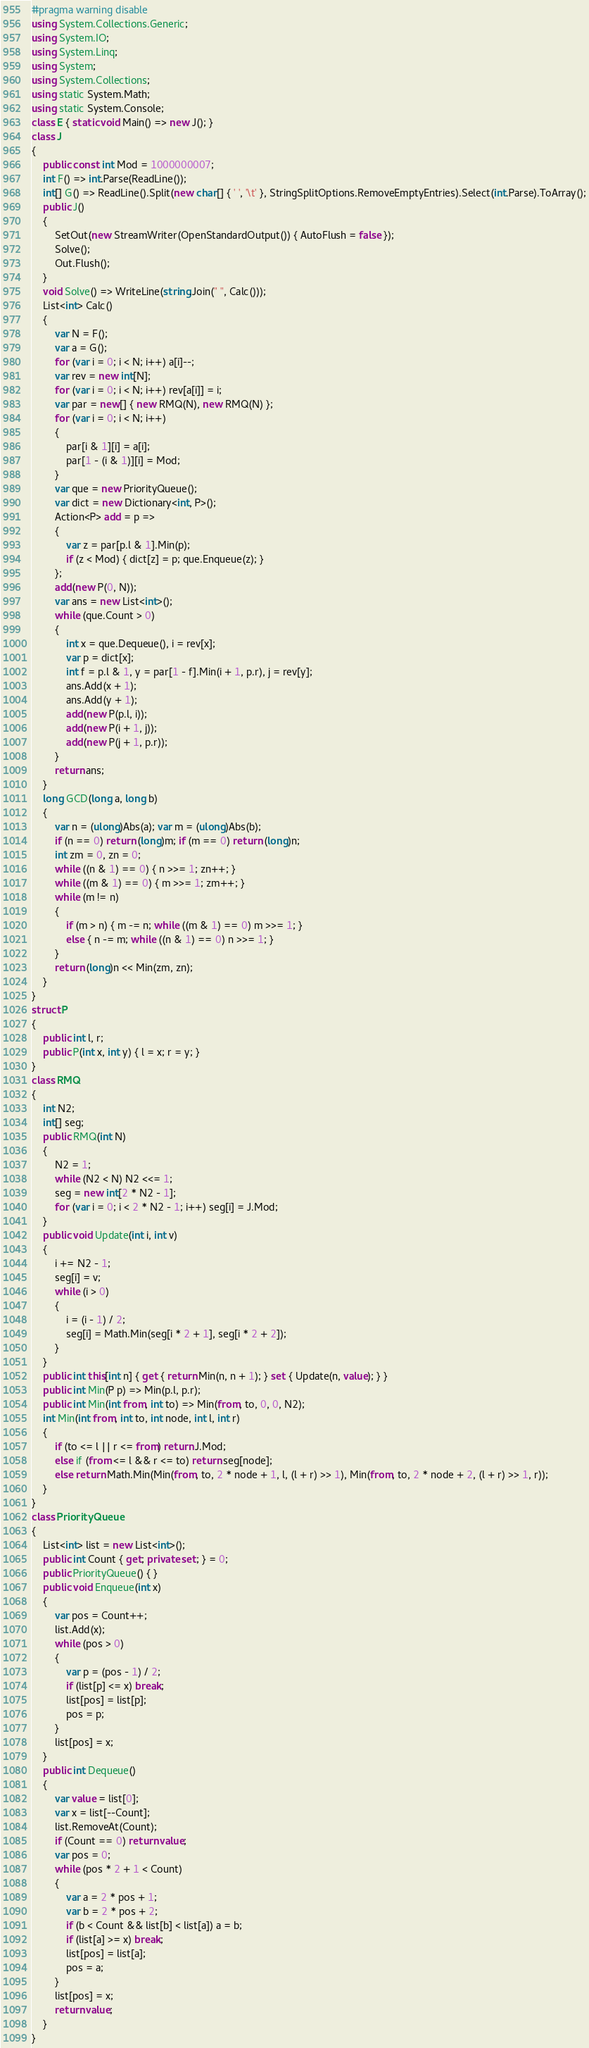Convert code to text. <code><loc_0><loc_0><loc_500><loc_500><_C#_>#pragma warning disable
using System.Collections.Generic;
using System.IO;
using System.Linq;
using System;
using System.Collections;
using static System.Math;
using static System.Console;
class E { static void Main() => new J(); }
class J
{
	public const int Mod = 1000000007;
	int F() => int.Parse(ReadLine());
	int[] G() => ReadLine().Split(new char[] { ' ', '\t' }, StringSplitOptions.RemoveEmptyEntries).Select(int.Parse).ToArray();
	public J()
	{
		SetOut(new StreamWriter(OpenStandardOutput()) { AutoFlush = false });
		Solve();
		Out.Flush();
	}
	void Solve() => WriteLine(string.Join(" ", Calc()));
	List<int> Calc()
	{
		var N = F();
		var a = G();
		for (var i = 0; i < N; i++) a[i]--;
		var rev = new int[N];
		for (var i = 0; i < N; i++) rev[a[i]] = i;
		var par = new[] { new RMQ(N), new RMQ(N) };
		for (var i = 0; i < N; i++)
		{
			par[i & 1][i] = a[i];
			par[1 - (i & 1)][i] = Mod;
		}
		var que = new PriorityQueue();
		var dict = new Dictionary<int, P>();
		Action<P> add = p =>
		{
			var z = par[p.l & 1].Min(p);
			if (z < Mod) { dict[z] = p; que.Enqueue(z); }
		};
		add(new P(0, N));
		var ans = new List<int>();
		while (que.Count > 0)
		{
			int x = que.Dequeue(), i = rev[x];
			var p = dict[x];
			int f = p.l & 1, y = par[1 - f].Min(i + 1, p.r), j = rev[y];
			ans.Add(x + 1);
			ans.Add(y + 1);
			add(new P(p.l, i));
			add(new P(i + 1, j));
			add(new P(j + 1, p.r));
		}
		return ans;
	}
	long GCD(long a, long b)
	{
		var n = (ulong)Abs(a); var m = (ulong)Abs(b);
		if (n == 0) return (long)m; if (m == 0) return (long)n;
		int zm = 0, zn = 0;
		while ((n & 1) == 0) { n >>= 1; zn++; }
		while ((m & 1) == 0) { m >>= 1; zm++; }
		while (m != n)
		{
			if (m > n) { m -= n; while ((m & 1) == 0) m >>= 1; }
			else { n -= m; while ((n & 1) == 0) n >>= 1; }
		}
		return (long)n << Min(zm, zn);
	}
}
struct P
{
	public int l, r;
	public P(int x, int y) { l = x; r = y; }
}
class RMQ
{
	int N2;
	int[] seg;
	public RMQ(int N)
	{
		N2 = 1;
		while (N2 < N) N2 <<= 1;
		seg = new int[2 * N2 - 1];
		for (var i = 0; i < 2 * N2 - 1; i++) seg[i] = J.Mod;
	}
	public void Update(int i, int v)
	{
		i += N2 - 1;
		seg[i] = v;
		while (i > 0)
		{
			i = (i - 1) / 2;
			seg[i] = Math.Min(seg[i * 2 + 1], seg[i * 2 + 2]);
		}
	}
	public int this[int n] { get { return Min(n, n + 1); } set { Update(n, value); } }
	public int Min(P p) => Min(p.l, p.r);
	public int Min(int from, int to) => Min(from, to, 0, 0, N2);
	int Min(int from, int to, int node, int l, int r)
	{
		if (to <= l || r <= from) return J.Mod;
		else if (from <= l && r <= to) return seg[node];
		else return Math.Min(Min(from, to, 2 * node + 1, l, (l + r) >> 1), Min(from, to, 2 * node + 2, (l + r) >> 1, r));
	}
}
class PriorityQueue
{
	List<int> list = new List<int>();
	public int Count { get; private set; } = 0;
	public PriorityQueue() { }
	public void Enqueue(int x)
	{
		var pos = Count++;
		list.Add(x);
		while (pos > 0)
		{
			var p = (pos - 1) / 2;
			if (list[p] <= x) break;
			list[pos] = list[p];
			pos = p;
		}
		list[pos] = x;
	}
	public int Dequeue()
	{
		var value = list[0];
		var x = list[--Count];
		list.RemoveAt(Count);
		if (Count == 0) return value;
		var pos = 0;
		while (pos * 2 + 1 < Count)
		{
			var a = 2 * pos + 1;
			var b = 2 * pos + 2;
			if (b < Count && list[b] < list[a]) a = b;
			if (list[a] >= x) break;
			list[pos] = list[a];
			pos = a;
		}
		list[pos] = x;
		return value;
	}
}</code> 